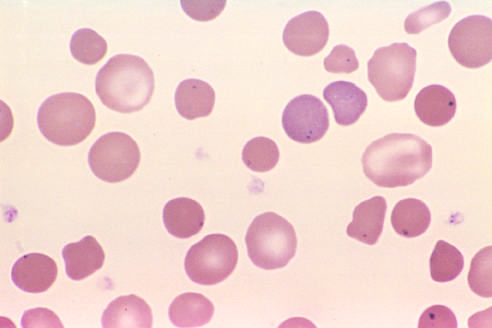where are howell-jolly bodies present?
Answer the question using a single word or phrase. In the red cells of this asplenic patient 